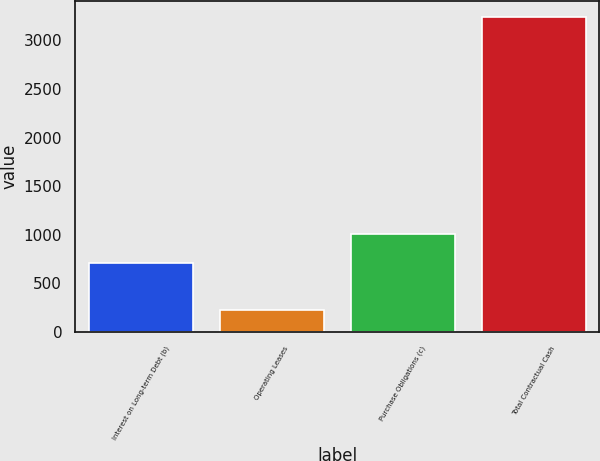Convert chart. <chart><loc_0><loc_0><loc_500><loc_500><bar_chart><fcel>Interest on Long-term Debt (b)<fcel>Operating Leases<fcel>Purchase Obligations (c)<fcel>Total Contractual Cash<nl><fcel>705<fcel>223<fcel>1007<fcel>3243<nl></chart> 